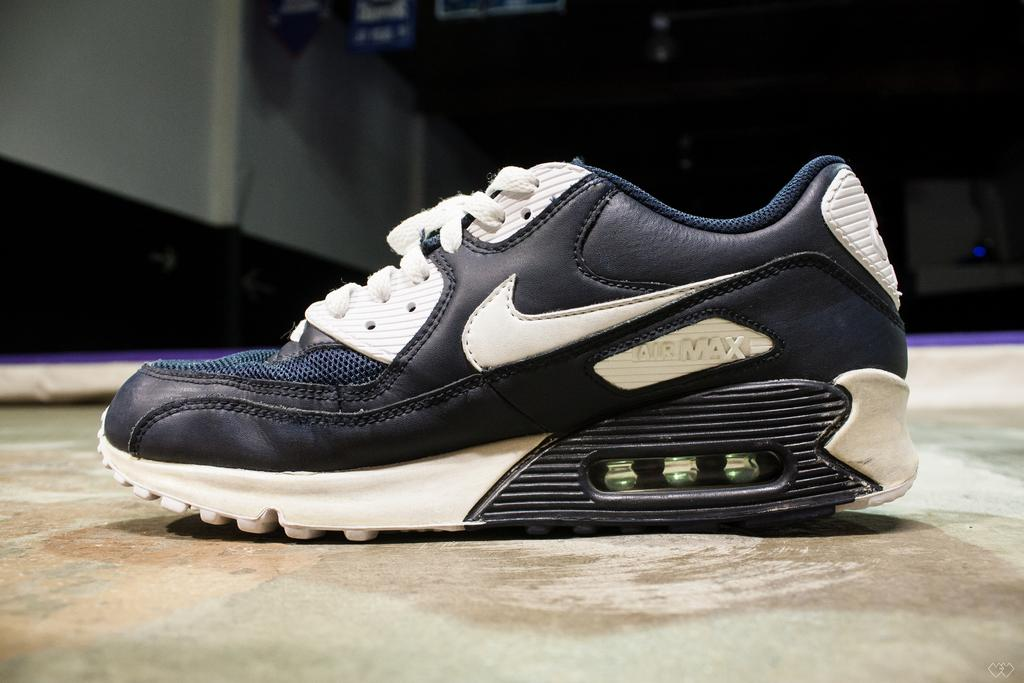What is placed on the floor in the image? There is a shoe placed on the floor in the image. What statement is being made by the shoe in the image? The shoe in the image is not making any statements, as it is an inanimate object and cannot communicate verbally. 